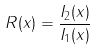<formula> <loc_0><loc_0><loc_500><loc_500>R ( x ) = \frac { I _ { 2 } ( x ) } { I _ { 1 } ( x ) }</formula> 